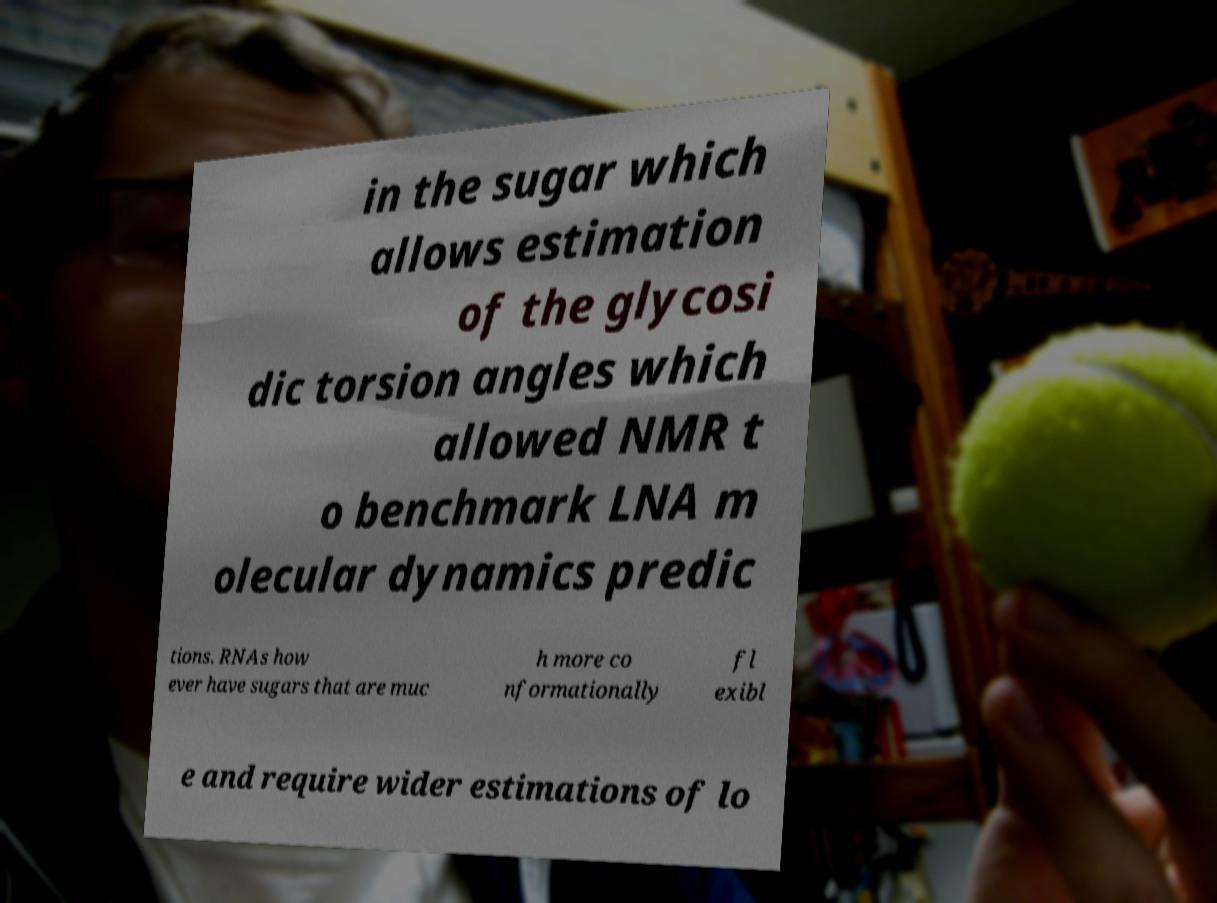Please identify and transcribe the text found in this image. in the sugar which allows estimation of the glycosi dic torsion angles which allowed NMR t o benchmark LNA m olecular dynamics predic tions. RNAs how ever have sugars that are muc h more co nformationally fl exibl e and require wider estimations of lo 